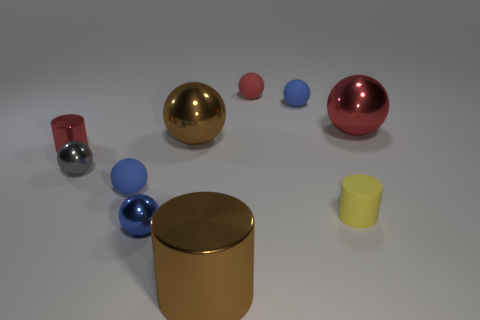Subtract all gray cylinders. How many blue spheres are left? 3 Subtract all blue balls. How many balls are left? 4 Subtract all large spheres. How many spheres are left? 5 Subtract 1 balls. How many balls are left? 6 Subtract all brown spheres. Subtract all gray cylinders. How many spheres are left? 6 Subtract all balls. How many objects are left? 3 Subtract all red matte objects. Subtract all brown metal balls. How many objects are left? 8 Add 5 big spheres. How many big spheres are left? 7 Add 1 small brown rubber objects. How many small brown rubber objects exist? 1 Subtract 0 green balls. How many objects are left? 10 